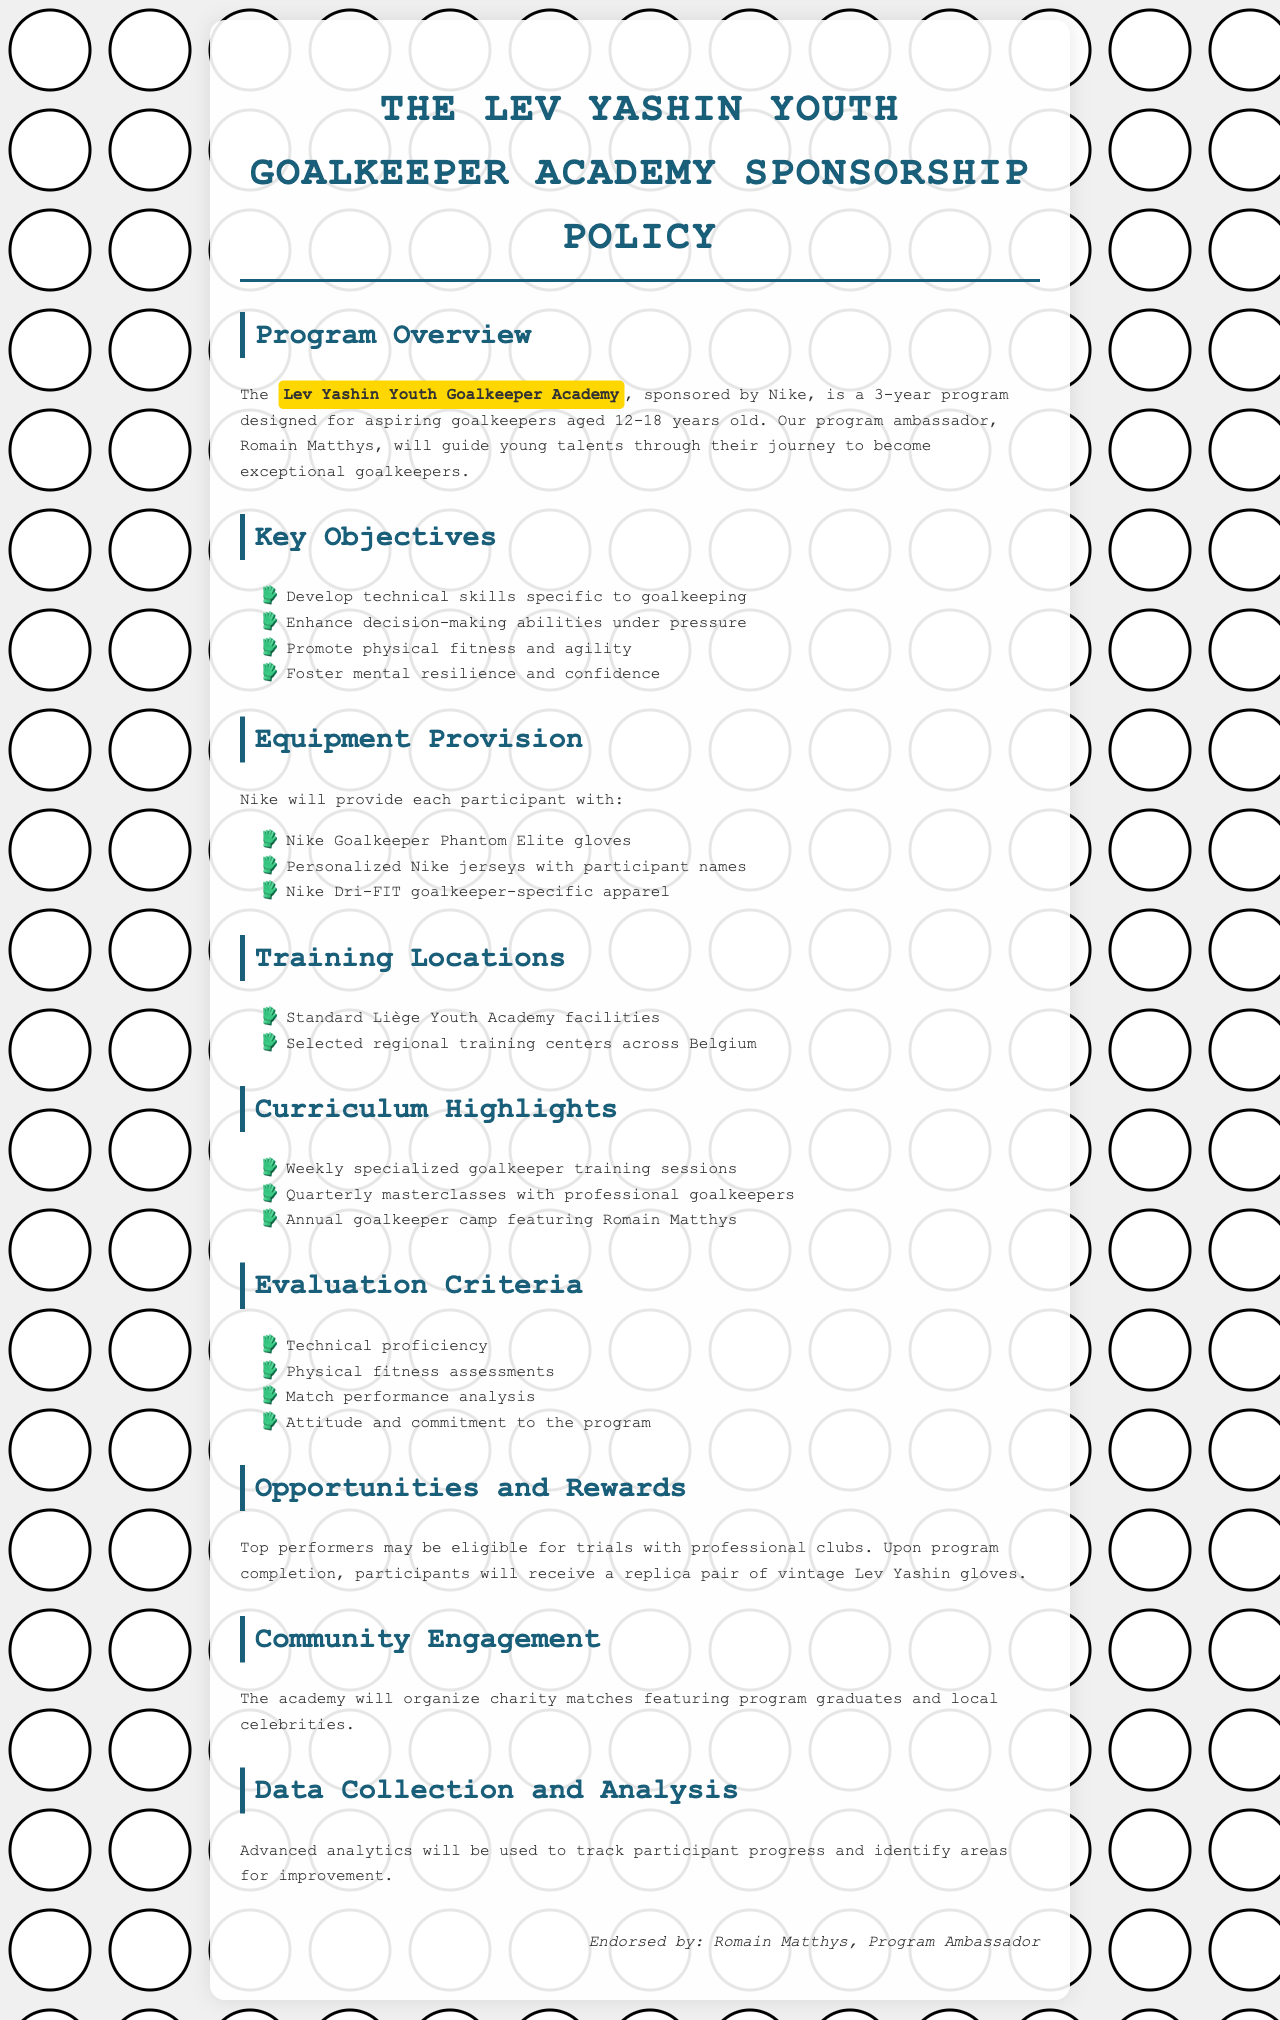What is the name of the academy? The name of the academy is explicitly stated in the document as the Lev Yashin Youth Goalkeeper Academy.
Answer: Lev Yashin Youth Goalkeeper Academy Who is the program ambassador? The document specifically names Romain Matthys as the program ambassador.
Answer: Romain Matthys How long is the program? The document mentions that the program is a three-year initiative designed for young goalkeepers.
Answer: 3 years What is provided to each participant? The document lists equipment provided by Nike to participants such as gloves, jerseys, and apparel.
Answer: Nike Goalkeeper Phantom Elite gloves What age group does the program target? The age range explicitly mentioned in the document for participants is 12 to 18 years old.
Answer: 12-18 years old What are top performers eligible for? The document states that top performers may be eligible for specific opportunities after the program.
Answer: Trials with professional clubs Which training locations are mentioned? The document specifies locations where the training will take place, including the Standard Liège Youth Academy facilities and others.
Answer: Standard Liège Youth Academy facilities What kind of events will be organized by the academy? The document indicates that charity matches involving program graduates will take place.
Answer: Charity matches What will participants receive upon completion of the program? The document details that upon completion, participants will receive a specific item related to Lev Yashin.
Answer: A replica pair of vintage Lev Yashin gloves 